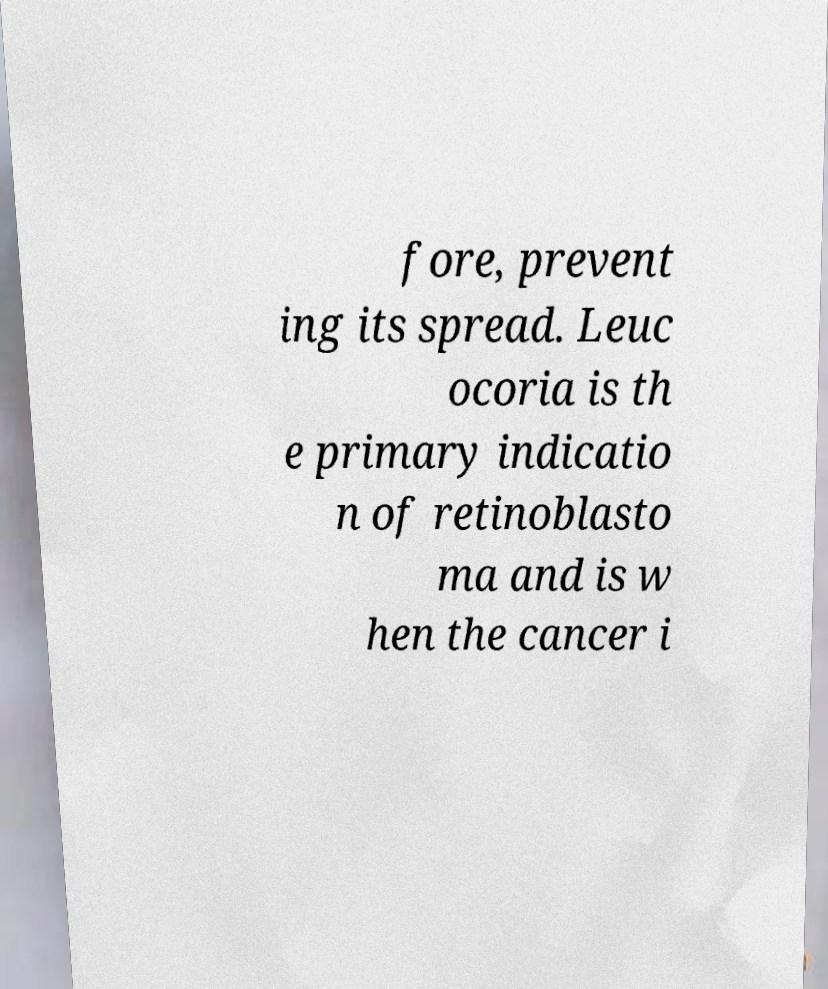Can you accurately transcribe the text from the provided image for me? fore, prevent ing its spread. Leuc ocoria is th e primary indicatio n of retinoblasto ma and is w hen the cancer i 